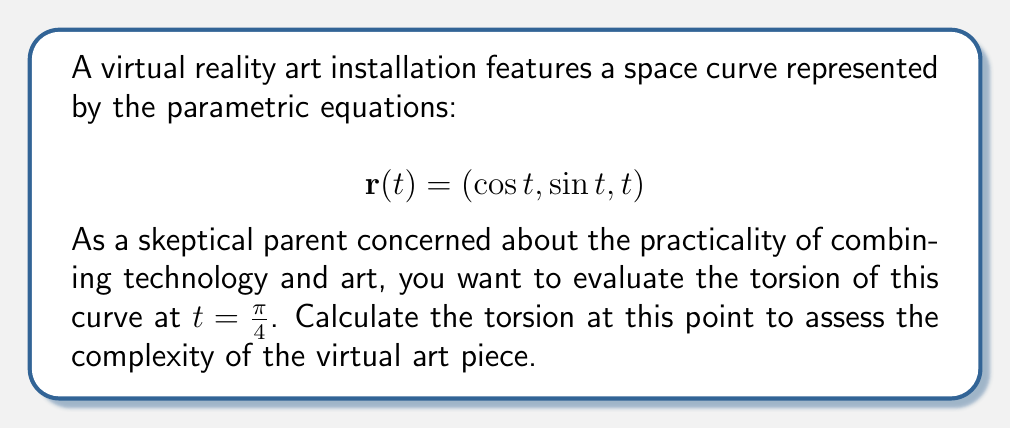What is the answer to this math problem? To evaluate the torsion of the space curve, we'll follow these steps:

1) The torsion of a space curve is given by the formula:

   $$\tau = \frac{(r'(t) \times r''(t)) \cdot r'''(t)}{|r'(t) \times r''(t)|^2}$$

2) First, let's calculate $r'(t)$, $r''(t)$, and $r'''(t)$:

   $$r'(t) = (-\sin t, \cos t, 1)$$
   $$r''(t) = (-\cos t, -\sin t, 0)$$
   $$r'''(t) = (\sin t, -\cos t, 0)$$

3) Now, let's calculate $r'(t) \times r''(t)$:

   $$r'(t) \times r''(t) = \begin{vmatrix} 
   i & j & k \\
   -\sin t & \cos t & 1 \\
   -\cos t & -\sin t & 0
   \end{vmatrix} = (\sin t, \cos t, 1)$$

4) Next, we calculate $(r'(t) \times r''(t)) \cdot r'''(t)$:

   $$(\sin t, \cos t, 1) \cdot (\sin t, -\cos t, 0) = \sin^2 t - \cos^2 t = -\cos 2t$$

5) We also need $|r'(t) \times r''(t)|^2$:

   $$|r'(t) \times r''(t)|^2 = \sin^2 t + \cos^2 t + 1 = 2$$

6) Now we can substitute these into the torsion formula:

   $$\tau = \frac{-\cos 2t}{2}$$

7) At $t = \frac{\pi}{4}$, we have:

   $$\tau = \frac{-\cos (2\cdot\frac{\pi}{4})}{2} = \frac{-\cos \frac{\pi}{2}}{2} = 0$$

Therefore, the torsion at $t = \frac{\pi}{4}$ is 0.
Answer: 0 